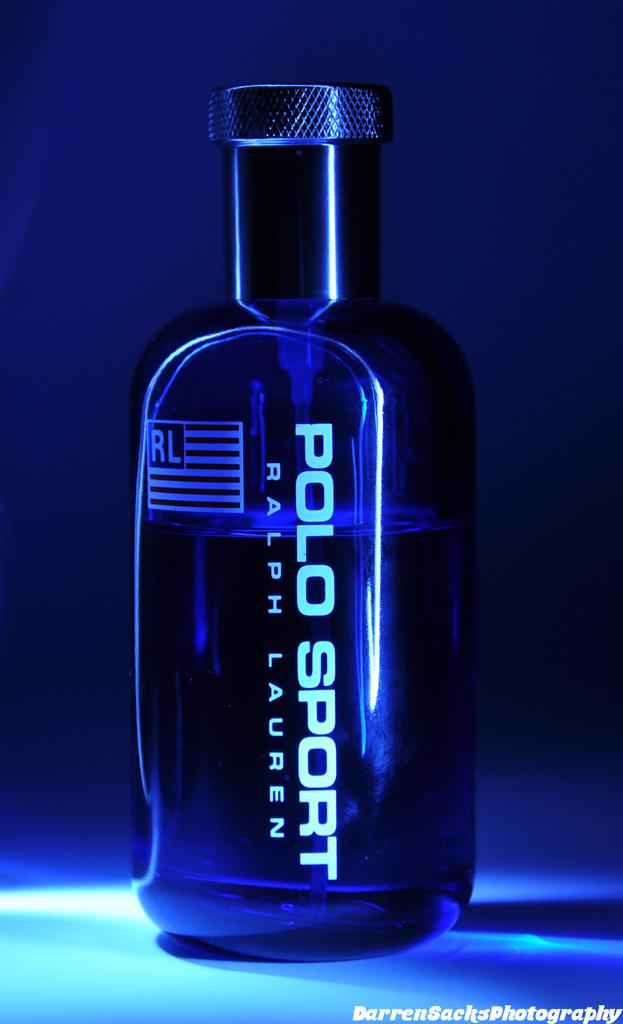Provide a one-sentence caption for the provided image. Polo Sport by Ralph Lauren is printed on the side of this bottle. 